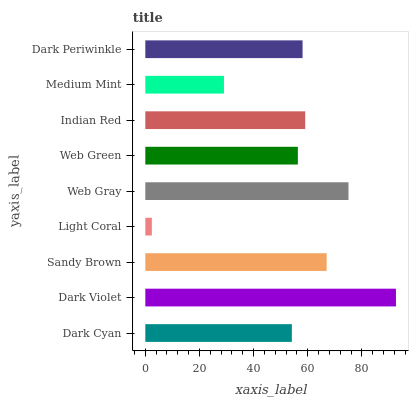Is Light Coral the minimum?
Answer yes or no. Yes. Is Dark Violet the maximum?
Answer yes or no. Yes. Is Sandy Brown the minimum?
Answer yes or no. No. Is Sandy Brown the maximum?
Answer yes or no. No. Is Dark Violet greater than Sandy Brown?
Answer yes or no. Yes. Is Sandy Brown less than Dark Violet?
Answer yes or no. Yes. Is Sandy Brown greater than Dark Violet?
Answer yes or no. No. Is Dark Violet less than Sandy Brown?
Answer yes or no. No. Is Dark Periwinkle the high median?
Answer yes or no. Yes. Is Dark Periwinkle the low median?
Answer yes or no. Yes. Is Light Coral the high median?
Answer yes or no. No. Is Dark Cyan the low median?
Answer yes or no. No. 